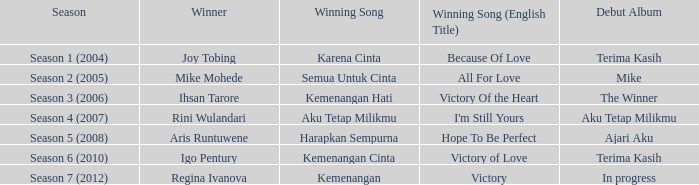Which winning song was sung by aku tetap milikmu? I'm Still Yours. 